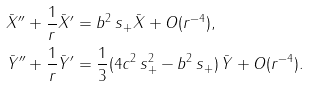<formula> <loc_0><loc_0><loc_500><loc_500>\bar { X } ^ { \prime \prime } + \frac { 1 } { r } \bar { X } ^ { \prime } & = b ^ { 2 } \, s _ { + } \bar { X } + O ( r ^ { - 4 } ) , \\ \bar { Y } ^ { \prime \prime } + \frac { 1 } { r } \bar { Y } ^ { \prime } & = \frac { 1 } { 3 } ( 4 c ^ { 2 } \, s _ { + } ^ { 2 } - b ^ { 2 } \, s _ { + } ) \, \bar { Y } + O ( r ^ { - 4 } ) .</formula> 